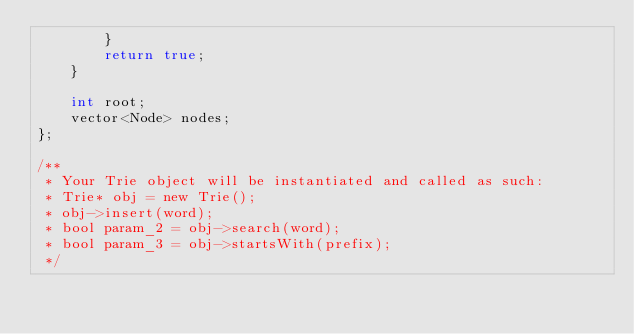<code> <loc_0><loc_0><loc_500><loc_500><_C++_>        }
        return true;
    }

    int root;
    vector<Node> nodes;
};

/**
 * Your Trie object will be instantiated and called as such:
 * Trie* obj = new Trie();
 * obj->insert(word);
 * bool param_2 = obj->search(word);
 * bool param_3 = obj->startsWith(prefix);
 */
</code> 